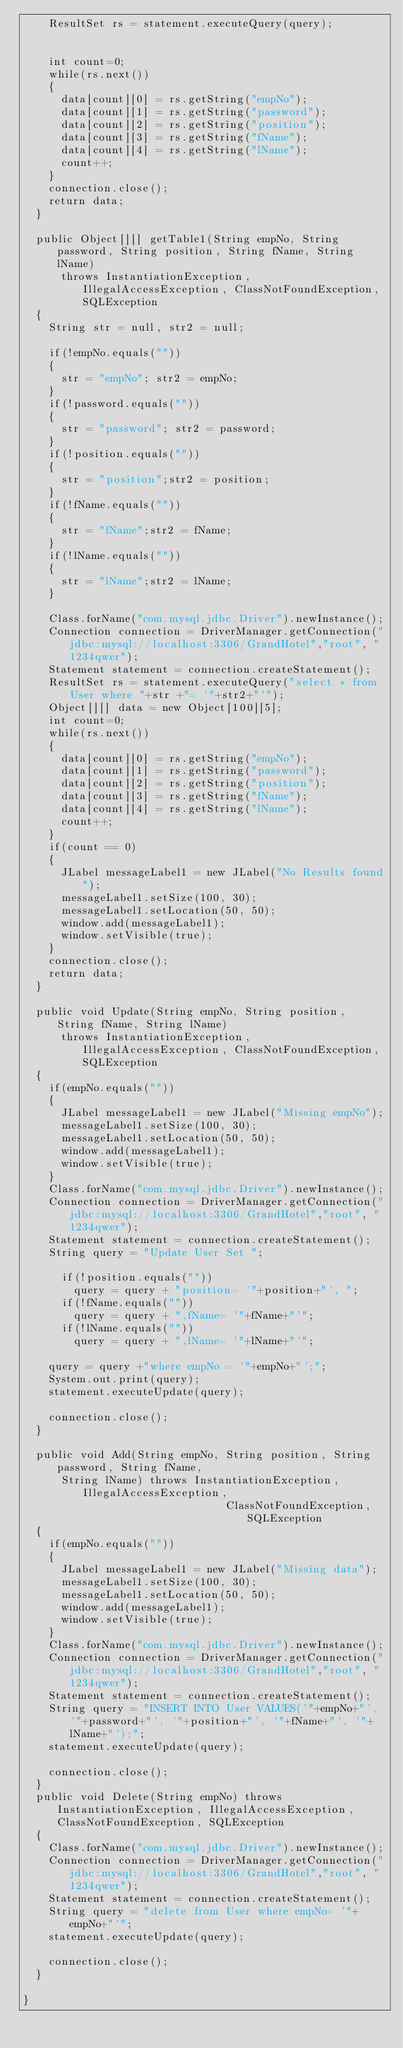Convert code to text. <code><loc_0><loc_0><loc_500><loc_500><_Java_>		ResultSet rs = statement.executeQuery(query);

		
		int count=0;
		while(rs.next())
		{
			data[count][0] = rs.getString("empNo");
			data[count][1] = rs.getString("password");
			data[count][2] = rs.getString("position");
			data[count][3] = rs.getString("fName");
			data[count][4] = rs.getString("lName");
			count++;
		}
		connection.close();
		return data;
	}
	
	public Object[][] getTable1(String empNo, String password, String position, String fName, String lName) 
			throws InstantiationException, IllegalAccessException, ClassNotFoundException, SQLException
	{
		String str = null, str2 = null; 
		
		if(!empNo.equals(""))
		{
			str = "empNo"; str2 = empNo;
		}
		if(!password.equals(""))
		{
			str = "password"; str2 = password;
		}
		if(!position.equals(""))
		{	
			str = "position";str2 = position;
		}
		if(!fName.equals(""))
		{
			str = "fName";str2 = fName;
		}
		if(!lName.equals(""))
		{
			str = "lName";str2 = lName;
		}
		
		Class.forName("com.mysql.jdbc.Driver").newInstance();
		Connection connection = DriverManager.getConnection("jdbc:mysql://localhost:3306/GrandHotel","root", "1234qwer");
		Statement statement = connection.createStatement();
		ResultSet rs = statement.executeQuery("select * from User where "+str +"= '"+str2+"'"); 
		Object[][] data = new Object[100][5];
		int count=0;
		while(rs.next())
		{
			data[count][0] = rs.getString("empNo");
			data[count][1] = rs.getString("password");
			data[count][2] = rs.getString("position");
			data[count][3] = rs.getString("fName");
			data[count][4] = rs.getString("lName");
			count++;
		}
		if(count == 0)
		{
			JLabel messageLabel1 = new JLabel("No Results found");
			messageLabel1.setSize(100, 30);
			messageLabel1.setLocation(50, 50);
			window.add(messageLabel1);
			window.setVisible(true);
		}
		connection.close();
		return data;
	}
	
	public void Update(String empNo, String position, String fName, String lName) 
			throws InstantiationException, IllegalAccessException, ClassNotFoundException, SQLException
	{
		if(empNo.equals(""))
		{
			JLabel messageLabel1 = new JLabel("Missing empNo");
			messageLabel1.setSize(100, 30);
			messageLabel1.setLocation(50, 50);
			window.add(messageLabel1);
			window.setVisible(true);
		}
		Class.forName("com.mysql.jdbc.Driver").newInstance();
		Connection connection = DriverManager.getConnection("jdbc:mysql://localhost:3306/GrandHotel","root", "1234qwer");
		Statement statement = connection.createStatement();
		String query = "Update User Set ";

			if(!position.equals(""))
				query = query + "position= '"+position+"', ";
			if(!fName.equals(""))
				query = query + ",fName= '"+fName+"'";
			if(!lName.equals(""))
				query = query + ",lName= '"+lName+"'";
		
		query = query +"where empNo = '"+empNo+"';";
		System.out.print(query);
		statement.executeUpdate(query);
		
		connection.close();
	}
	
	public void Add(String empNo, String position, String password, String fName, 
			String lName) throws InstantiationException, IllegalAccessException, 
																ClassNotFoundException, SQLException
	{
		if(empNo.equals(""))
		{
			JLabel messageLabel1 = new JLabel("Missing data");
			messageLabel1.setSize(100, 30);
			messageLabel1.setLocation(50, 50);
			window.add(messageLabel1);
			window.setVisible(true);
		}
		Class.forName("com.mysql.jdbc.Driver").newInstance();
		Connection connection = DriverManager.getConnection("jdbc:mysql://localhost:3306/GrandHotel","root", "1234qwer");
		Statement statement = connection.createStatement();
		String query = "INSERT INTO User VALUES('"+empNo+"', '"+password+"', '"+position+"', '"+fName+"', '"+lName+"');";
		statement.executeUpdate(query);
		
		connection.close();	
	}
	public void Delete(String empNo) throws InstantiationException, IllegalAccessException, ClassNotFoundException, SQLException
	{
		Class.forName("com.mysql.jdbc.Driver").newInstance();
		Connection connection = DriverManager.getConnection("jdbc:mysql://localhost:3306/GrandHotel","root", "1234qwer");
		Statement statement = connection.createStatement();
		String query = "delete from User where empNo= '"+empNo+"'";
		statement.executeUpdate(query);
		
		connection.close();
	}

}
</code> 